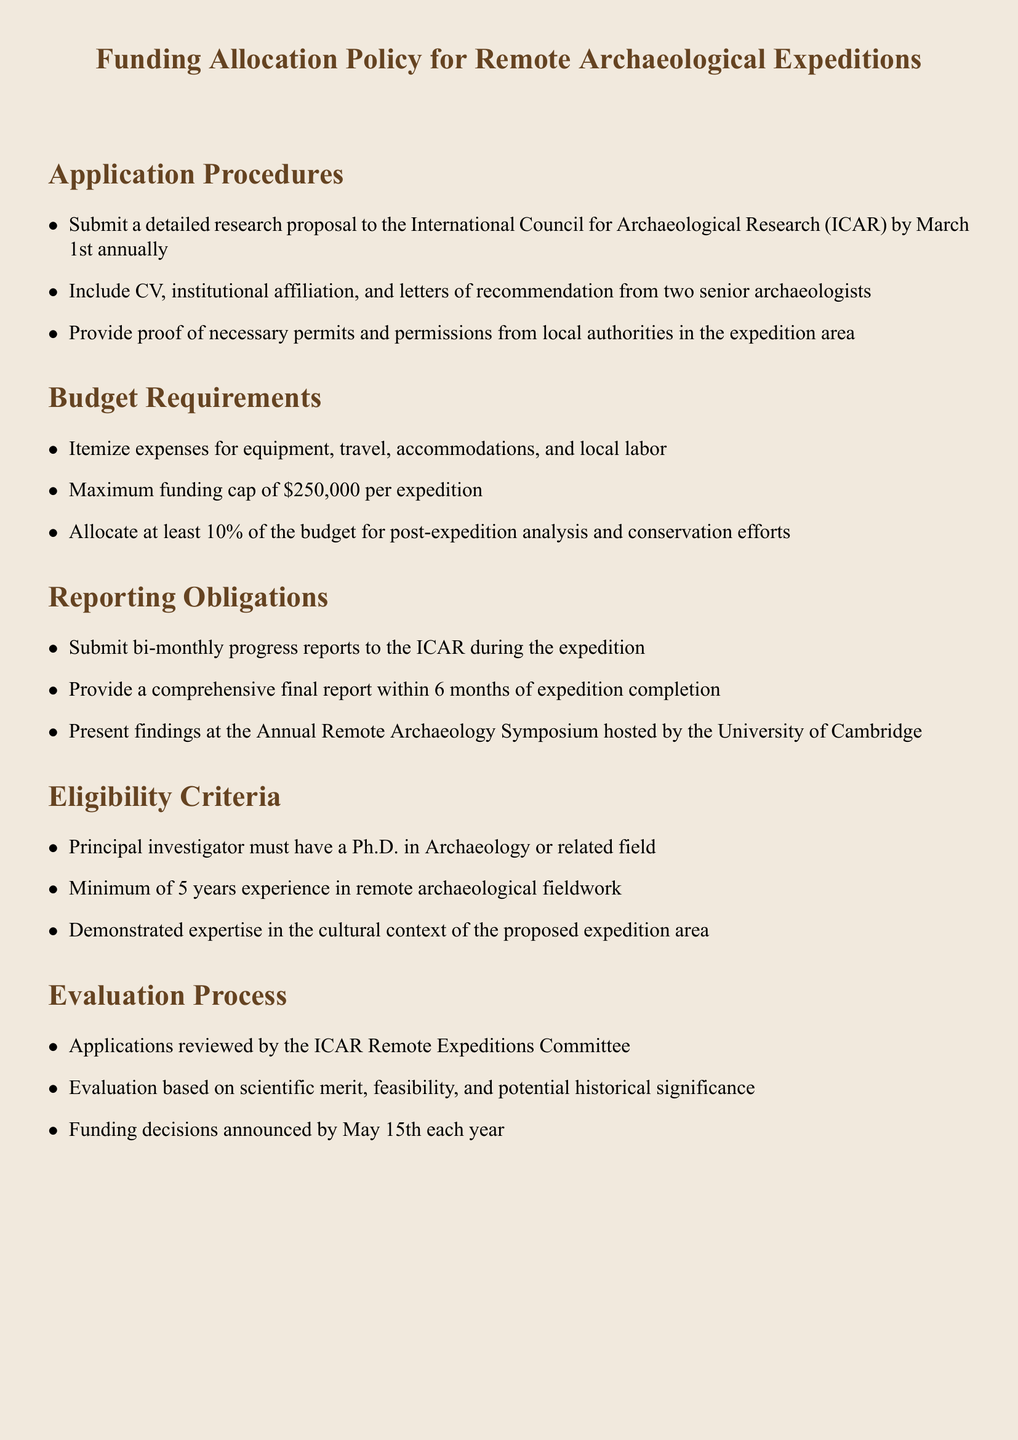What is the maximum funding cap per expedition? The funding cap is stated in the budget requirements section of the document as $250,000.
Answer: $250,000 When is the application deadline? The deadline for submitting a research proposal is explicitly mentioned as March 1st annually.
Answer: March 1st What is the minimum experience required for the principal investigator? The eligibility criteria section specifies that a minimum of 5 years experience in remote archaeological fieldwork is required.
Answer: 5 years Who reviews the applications? The evaluation process details that applications are reviewed by the ICAR Remote Expeditions Committee.
Answer: ICAR Remote Expeditions Committee What is required to be included in a research proposal submission? The application procedures list several necessities, one of which is the inclusion of a CV.
Answer: CV How often are progress reports due during the expedition? The reporting obligations section indicates that bi-monthly progress reports are required.
Answer: Bi-monthly What percentage of the budget must be allocated for post-expedition analysis? The budget requirements clearly state that at least 10% of the budget must be allocated for this purpose.
Answer: 10% What is the timeline for announcing funding decisions? The evaluation process section mentions that funding decisions are announced by May 15th each year.
Answer: May 15th Where must findings be presented following the expedition? The final report obligations specify that findings should be presented at the Annual Remote Archaeology Symposium hosted by the University of Cambridge.
Answer: University of Cambridge 